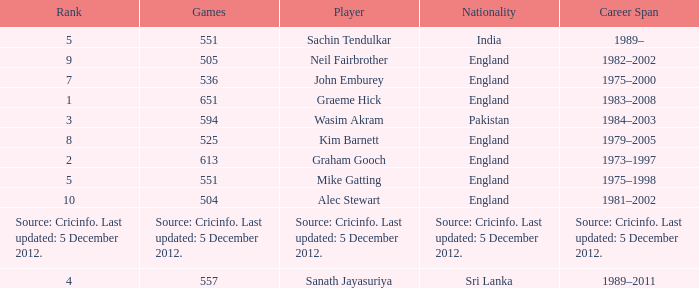What is the Nationality of Mike Gatting, who played 551 games? England. 